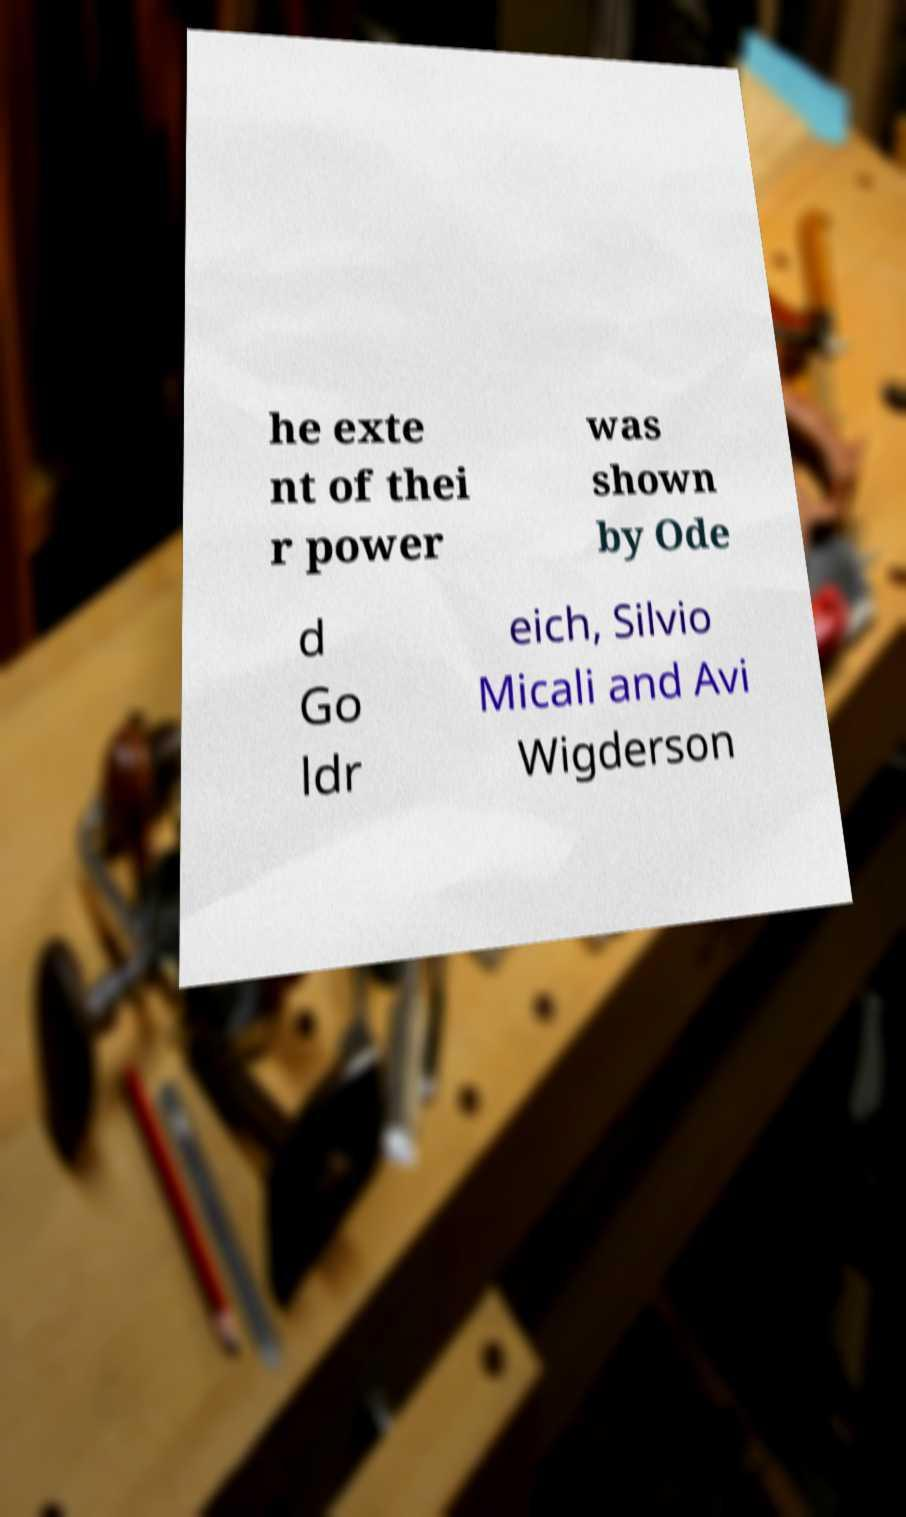For documentation purposes, I need the text within this image transcribed. Could you provide that? he exte nt of thei r power was shown by Ode d Go ldr eich, Silvio Micali and Avi Wigderson 